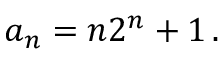Convert formula to latex. <formula><loc_0><loc_0><loc_500><loc_500>a _ { n } = n 2 ^ { n } + 1 \, .</formula> 